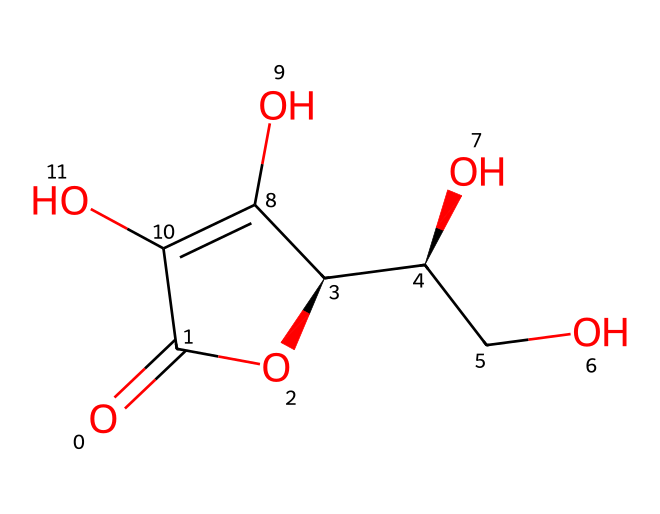What is the molecular formula of vitamin C? To find the molecular formula, count the number of each type of atom present in the structure. In this case, we have 6 carbon (C) atoms, 8 hydrogen (H) atoms, and 6 oxygen (O) atoms. Therefore, the molecular formula is C6H8O6.
Answer: C6H8O6 How many hydroxyl (–OH) groups are in vitamin C? By examining the chemical structure, we can identify the presence of hydroxyl groups. There are four distinct –OH groups attached to the carbon backbone of vitamin C.
Answer: 4 What functional group is present in vitamin C that contributes to its antioxidant properties? Vitamin C contains multiple hydroxyl (-OH) groups, which contribute to its ability to donate electrons and neutralize free radicals, characteristic of antioxidants.
Answer: hydroxyl Which element has the highest number of atoms in vitamin C? In the molecular formula C6H8O6, counting the number of atoms shows that there are more hydrogen (H) atoms (8) than carbon (C) or oxygen (O).
Answer: hydrogen How many rings are present in the chemical structure of vitamin C? Observing the structure, we see that vitamin C features a single cyclic structure or ring, which is common in many organic compounds.
Answer: 1 What type of structure does vitamin C represent? The structure of vitamin C exemplifies a cyclic structure due to the presence of a ring in its molecular arrangement, indicating it is a cyclic compound.
Answer: cyclic 